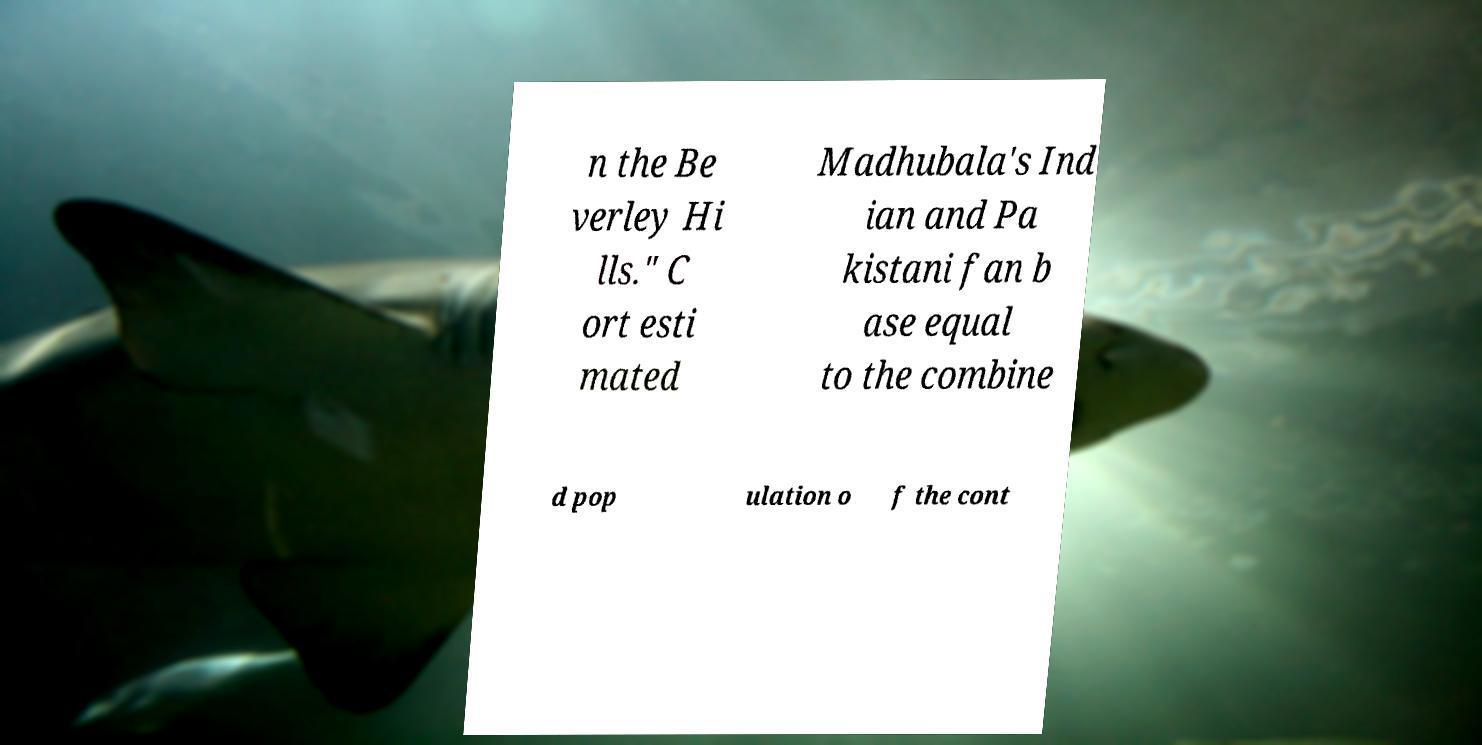Please identify and transcribe the text found in this image. n the Be verley Hi lls." C ort esti mated Madhubala's Ind ian and Pa kistani fan b ase equal to the combine d pop ulation o f the cont 